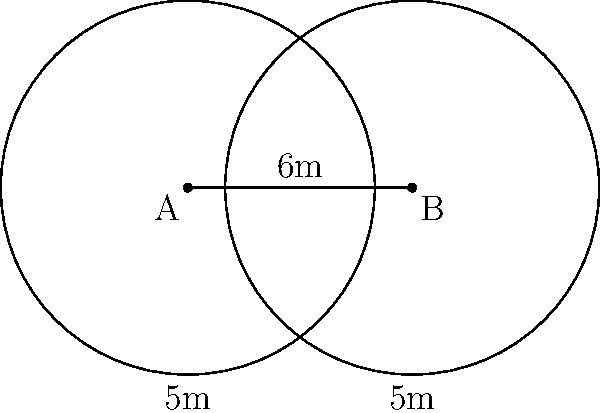During the 2022 Men's Softball World Championship, you're analyzing the outfield coverage. Two outfielders, positioned at points A and B, have circular coverage zones with a radius of 5 meters each. If the distance between the outfielders is 6 meters, what is the area of the overlapping region of their coverage zones? Round your answer to the nearest square meter. To find the area of overlap between two circular outfielder coverage zones, we'll follow these steps:

1) First, we need to find the angle θ at the center of each circle subtended by the chord of intersection:

   $$\cos(\frac{\theta}{2}) = \frac{d}{2r}$$

   where d is the distance between circle centers and r is the radius.

2) Substitute the values:
   $$\cos(\frac{\theta}{2}) = \frac{6}{2(5)} = \frac{3}{5}$$

3) Solve for θ:
   $$\theta = 2 \arccos(\frac{3}{5}) \approx 1.5912 \text{ radians}$$

4) The area of the circular sector with angle θ is:
   $$A_{sector} = \frac{1}{2}r^2\theta$$

5) The area of the triangle formed by the radius to the intersection points is:
   $$A_{triangle} = \frac{1}{2}r^2\sin(\theta)$$

6) The area of the lens-shaped overlap is twice the difference between these areas:
   $$A_{overlap} = 2(A_{sector} - A_{triangle})$$
   $$= 2(\frac{1}{2}r^2\theta - \frac{1}{2}r^2\sin(\theta))$$
   $$= r^2(\theta - \sin(\theta))$$

7) Substitute the values:
   $$A_{overlap} = 5^2(1.5912 - \sin(1.5912))$$
   $$\approx 25(1.5912 - 0.9996)$$
   $$\approx 14.79 \text{ square meters}$$

8) Rounding to the nearest square meter:
   $$A_{overlap} \approx 15 \text{ square meters}$$
Answer: 15 square meters 